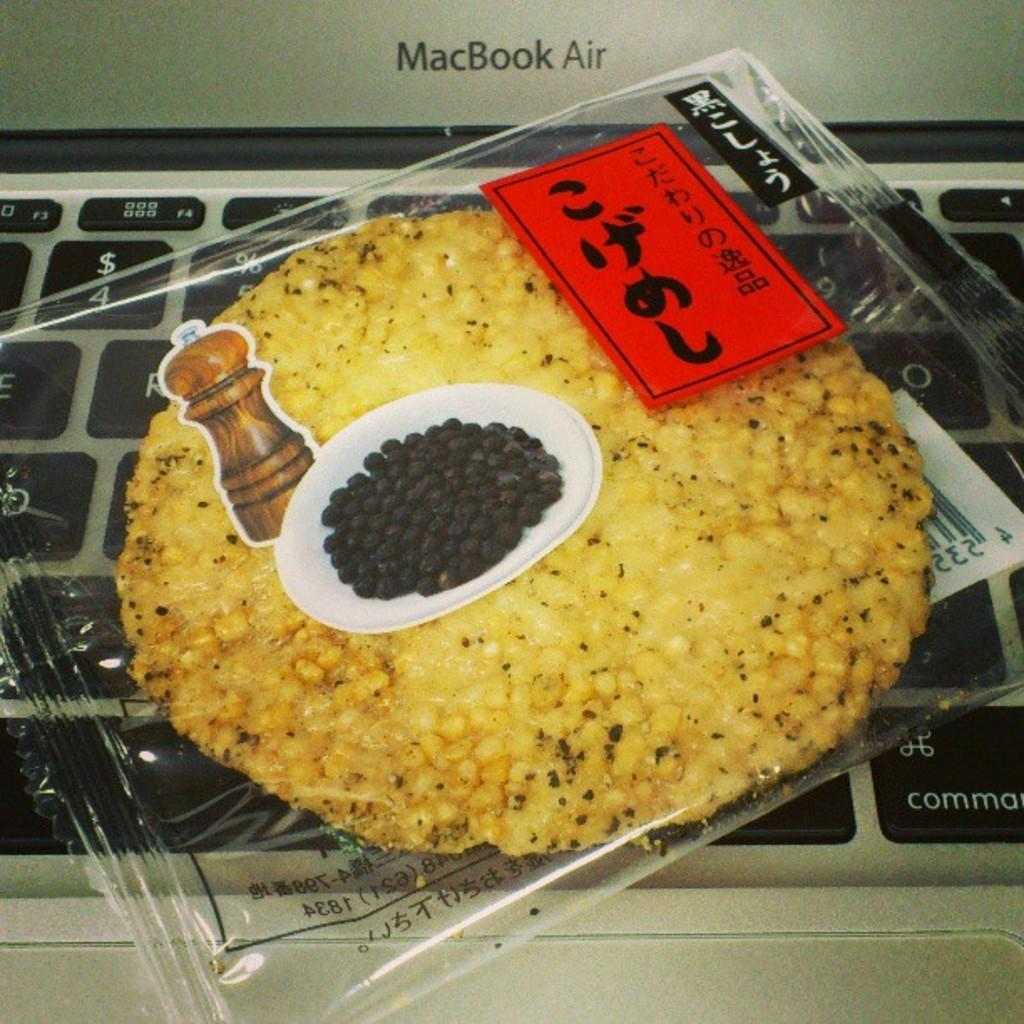What is inside the cover that is visible in the image? There is food inside the cover in the image. What decorative elements are present on the cover? There are stickers on the cover. What electronic device can be seen in the background of the image? There is a laptop visible in the background of the image, although it appears to be partially obscured or truncated. What type of advertisement is being displayed on the toy in the image? There is no toy present in the image, so it is not possible to determine if there is an advertisement being displayed on it. 